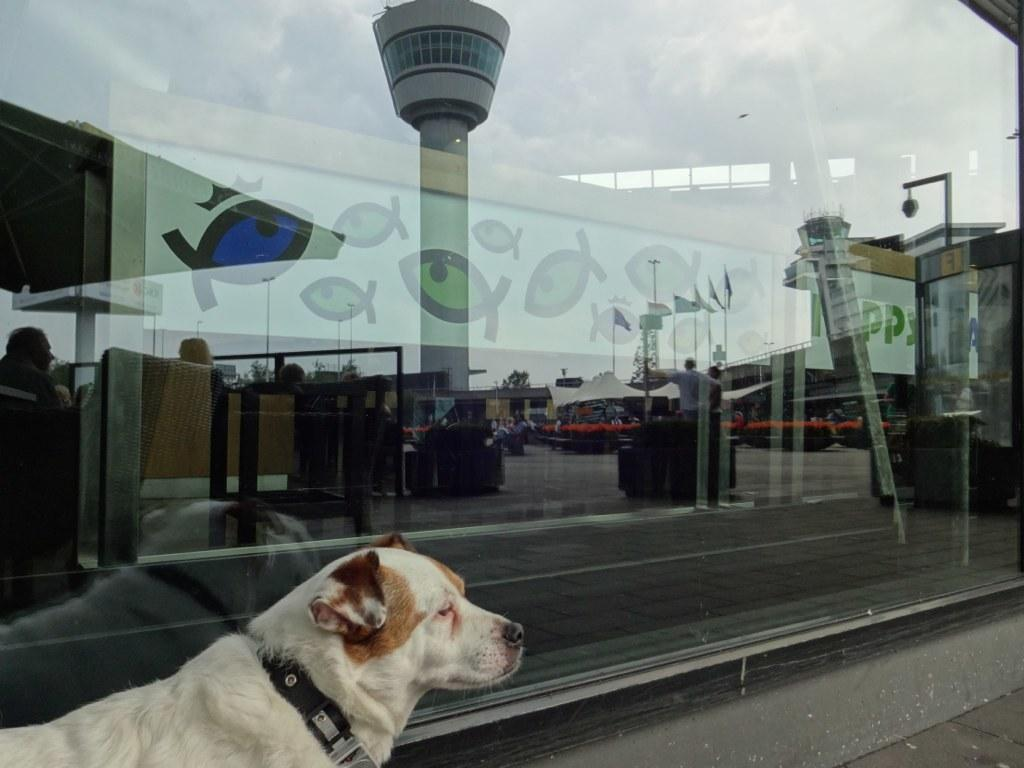What is the main subject in the front of the image? There is a dog in the front of the image. What can be seen in the background of the image? There is a glass in the background of the image. What does the glass reflect in the image? The glass reflects tents, flags, and a person. What type of island can be seen in the image? There is no island present in the image. How old is the daughter in the image? There is no daughter present in the image. 